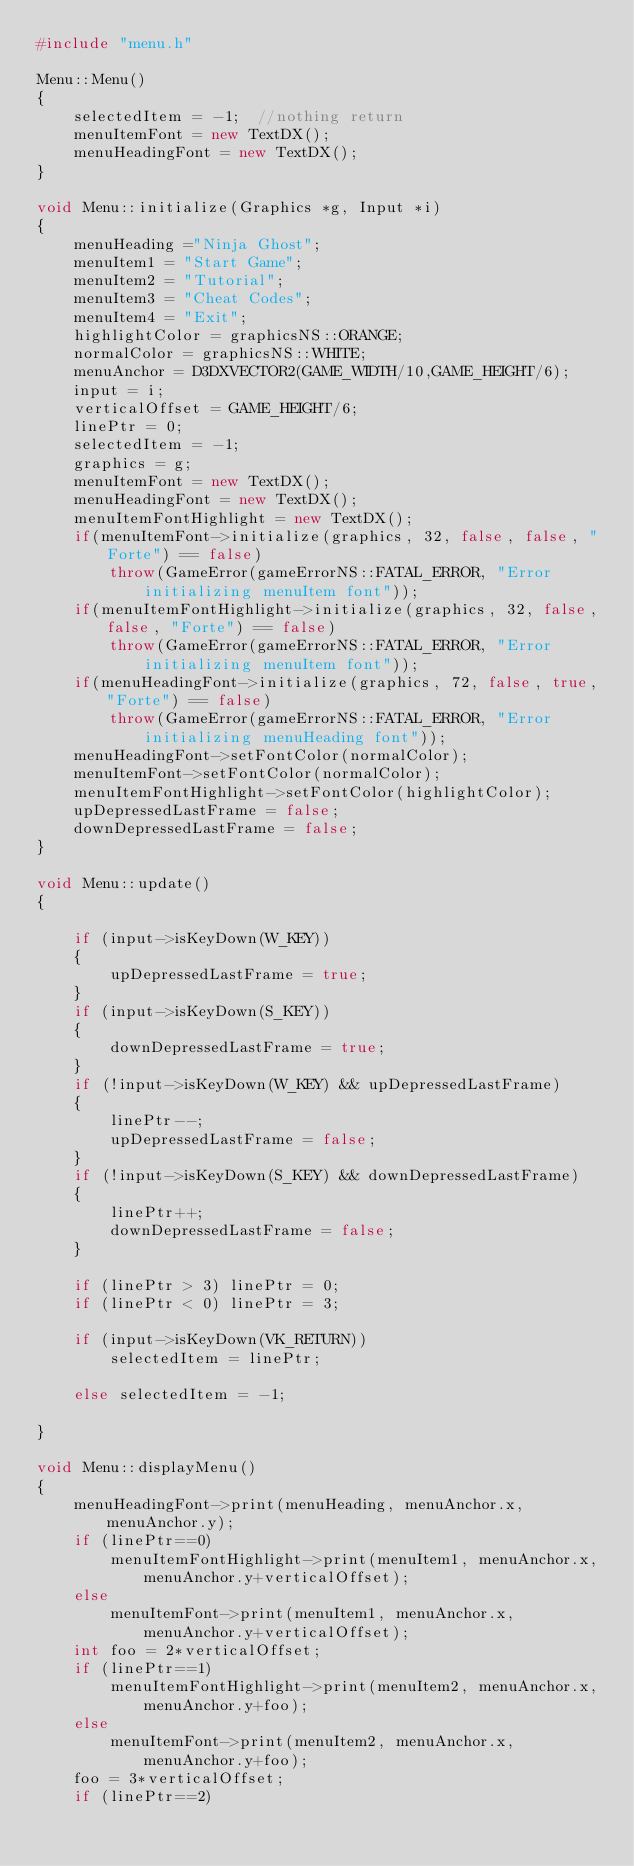Convert code to text. <code><loc_0><loc_0><loc_500><loc_500><_C++_>#include "menu.h"

Menu::Menu()
{
	selectedItem = -1;	//nothing return
	menuItemFont = new TextDX();
	menuHeadingFont = new TextDX();
}

void Menu::initialize(Graphics *g, Input *i)
{
	menuHeading ="Ninja Ghost";
	menuItem1 = "Start Game";
	menuItem2 = "Tutorial";
	menuItem3 = "Cheat Codes";
	menuItem4 = "Exit";
	highlightColor = graphicsNS::ORANGE;
	normalColor = graphicsNS::WHITE;
	menuAnchor = D3DXVECTOR2(GAME_WIDTH/10,GAME_HEIGHT/6);
	input = i;
	verticalOffset = GAME_HEIGHT/6;
	linePtr = 0;
	selectedItem = -1;
	graphics = g;
	menuItemFont = new TextDX();
	menuHeadingFont = new TextDX();
	menuItemFontHighlight = new TextDX();
	if(menuItemFont->initialize(graphics, 32, false, false, "Forte") == false)
        throw(GameError(gameErrorNS::FATAL_ERROR, "Error initializing menuItem font"));
	if(menuItemFontHighlight->initialize(graphics, 32, false, false, "Forte") == false)
        throw(GameError(gameErrorNS::FATAL_ERROR, "Error initializing menuItem font"));
	if(menuHeadingFont->initialize(graphics, 72, false, true, "Forte") == false)
        throw(GameError(gameErrorNS::FATAL_ERROR, "Error initializing menuHeading font"));
	menuHeadingFont->setFontColor(normalColor);
	menuItemFont->setFontColor(normalColor);
	menuItemFontHighlight->setFontColor(highlightColor);
	upDepressedLastFrame = false;
	downDepressedLastFrame = false;
}

void Menu::update()
{
	
	if (input->isKeyDown(W_KEY))
	{
		upDepressedLastFrame = true;
	}
	if (input->isKeyDown(S_KEY))
	{
		downDepressedLastFrame = true;
	}
	if (!input->isKeyDown(W_KEY) && upDepressedLastFrame)
	{
		linePtr--;
		upDepressedLastFrame = false;
	}
	if (!input->isKeyDown(S_KEY) && downDepressedLastFrame)
	{
		linePtr++;
		downDepressedLastFrame = false;
	}

	if (linePtr > 3) linePtr = 0;
	if (linePtr < 0) linePtr = 3;

	if (input->isKeyDown(VK_RETURN))
		selectedItem = linePtr;

	else selectedItem = -1;
	
}

void Menu::displayMenu()
{
	menuHeadingFont->print(menuHeading, menuAnchor.x, menuAnchor.y);
	if (linePtr==0)
		menuItemFontHighlight->print(menuItem1, menuAnchor.x, menuAnchor.y+verticalOffset);
	else
		menuItemFont->print(menuItem1, menuAnchor.x, menuAnchor.y+verticalOffset);
	int foo = 2*verticalOffset;
	if (linePtr==1)
		menuItemFontHighlight->print(menuItem2, menuAnchor.x, menuAnchor.y+foo);
	else
		menuItemFont->print(menuItem2, menuAnchor.x, menuAnchor.y+foo);
	foo = 3*verticalOffset;
	if (linePtr==2)</code> 